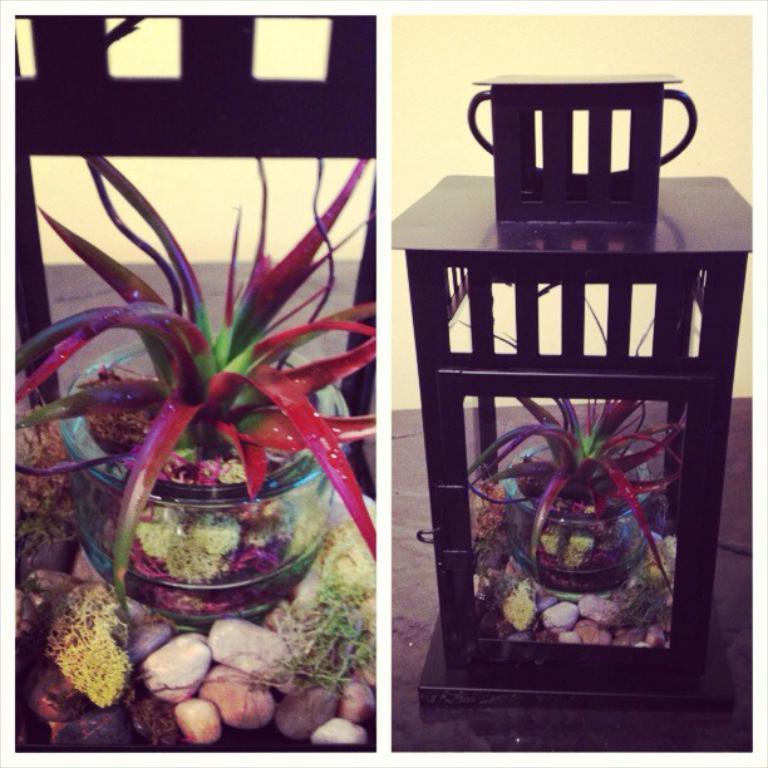How would you summarize this image in a sentence or two? In this image, we can see a glass box, in that there is a red and green color plants kept, there are some stones, at the right side we can see that object inside the table. 